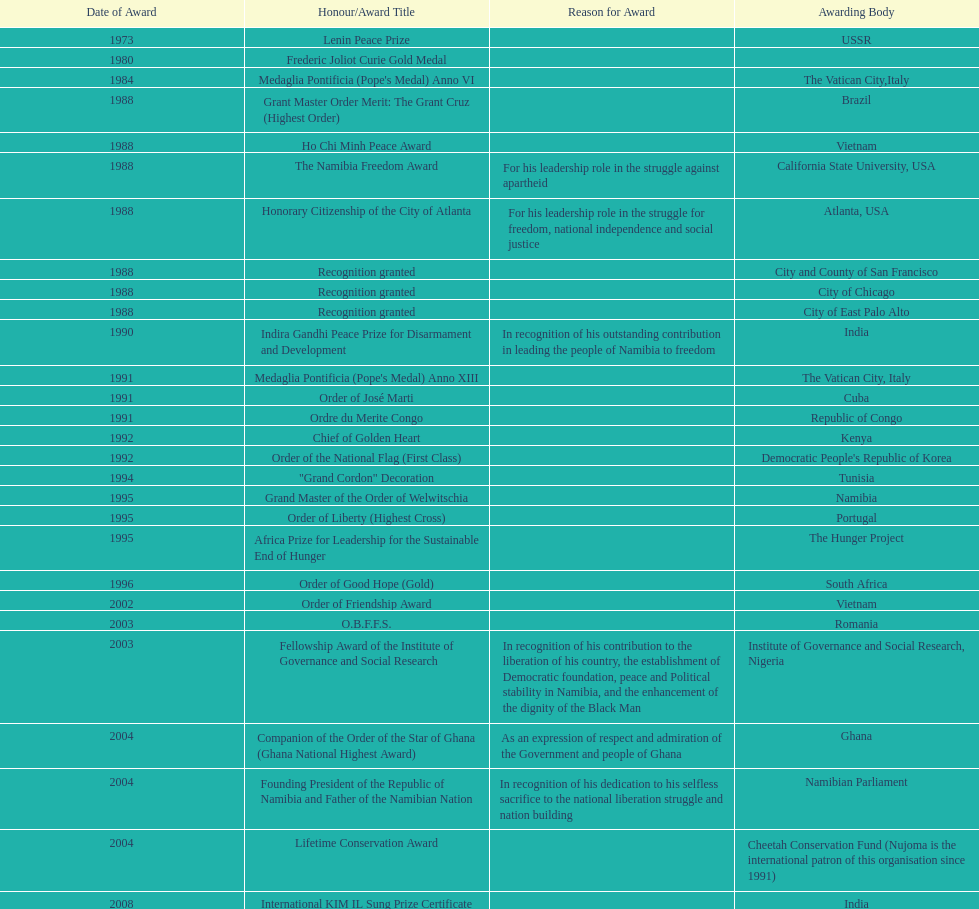What was the last award that nujoma won? Sir Seretse Khama SADC Meda. 